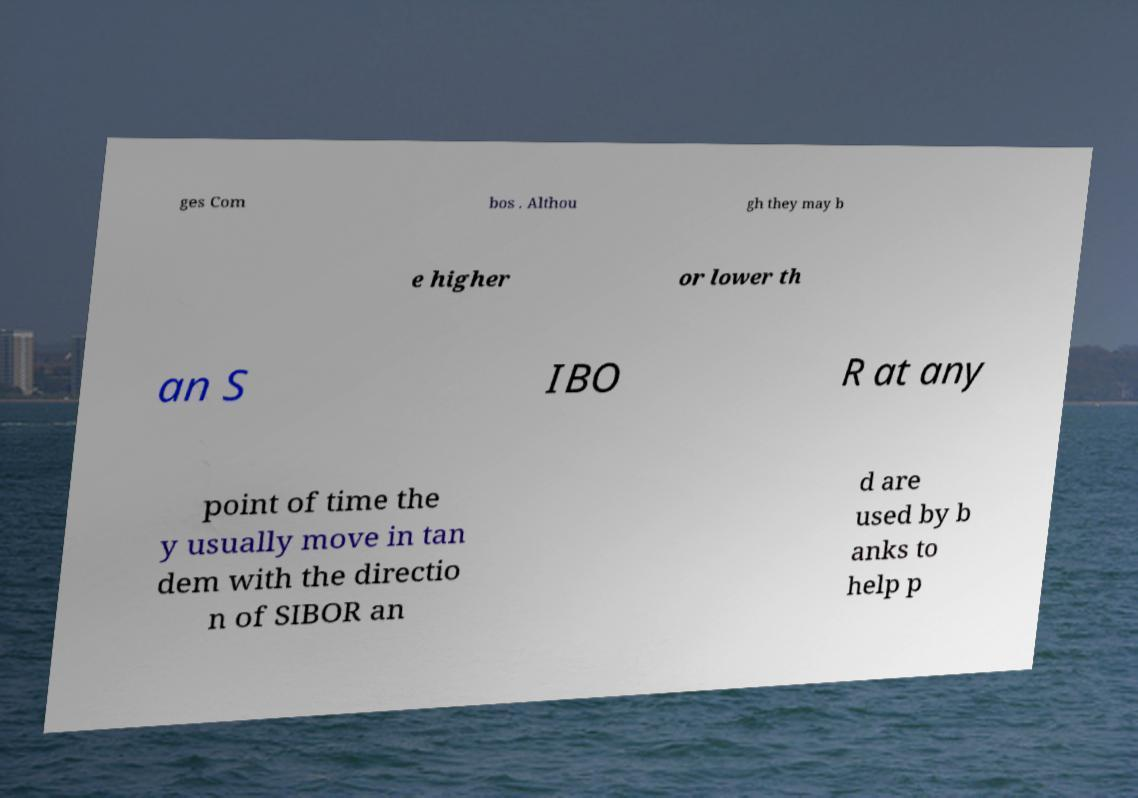I need the written content from this picture converted into text. Can you do that? ges Com bos . Althou gh they may b e higher or lower th an S IBO R at any point of time the y usually move in tan dem with the directio n of SIBOR an d are used by b anks to help p 